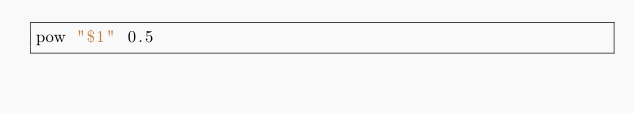<code> <loc_0><loc_0><loc_500><loc_500><_Bash_>pow "$1" 0.5
</code> 